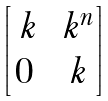<formula> <loc_0><loc_0><loc_500><loc_500>\begin{bmatrix} \ k & \ k ^ { n } \\ 0 & \ k \end{bmatrix}</formula> 